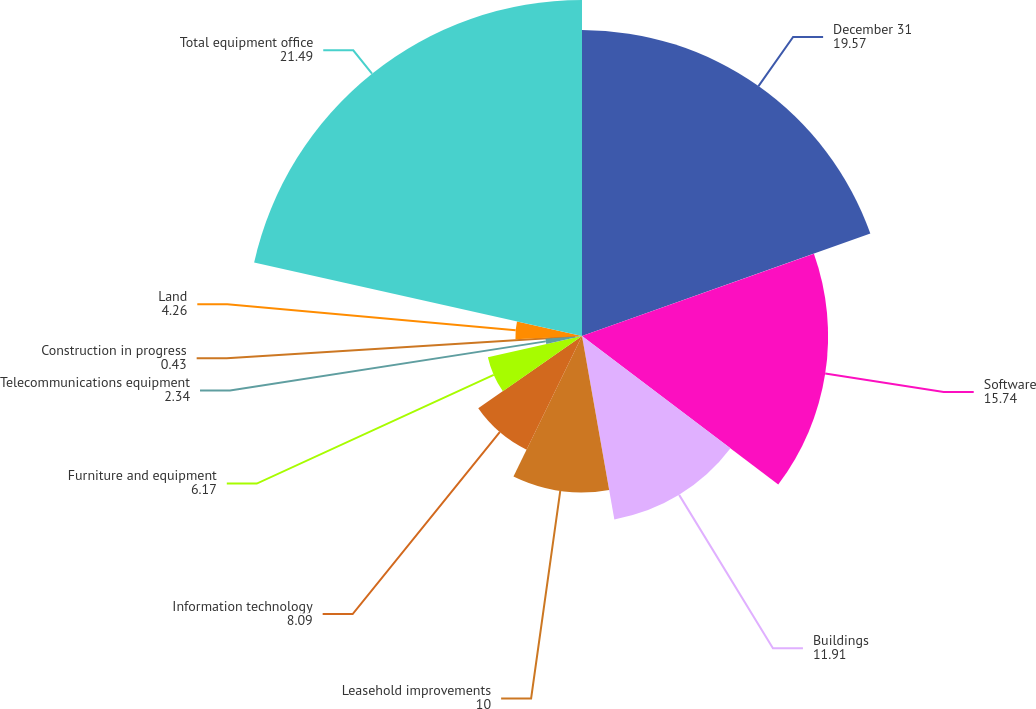Convert chart to OTSL. <chart><loc_0><loc_0><loc_500><loc_500><pie_chart><fcel>December 31<fcel>Software<fcel>Buildings<fcel>Leasehold improvements<fcel>Information technology<fcel>Furniture and equipment<fcel>Telecommunications equipment<fcel>Construction in progress<fcel>Land<fcel>Total equipment office<nl><fcel>19.57%<fcel>15.74%<fcel>11.91%<fcel>10.0%<fcel>8.09%<fcel>6.17%<fcel>2.34%<fcel>0.43%<fcel>4.26%<fcel>21.49%<nl></chart> 